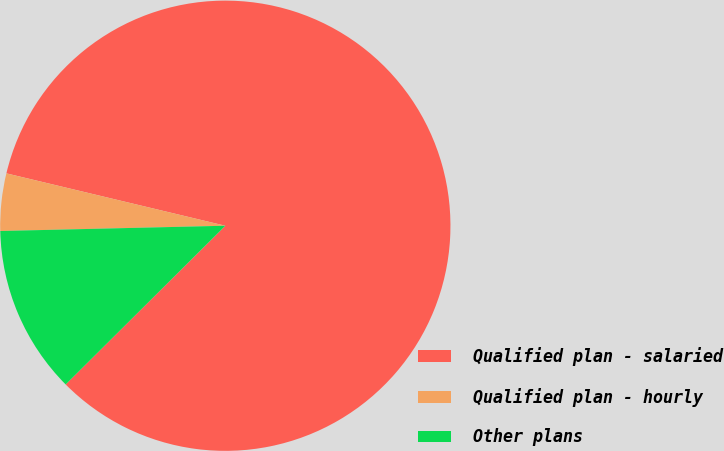<chart> <loc_0><loc_0><loc_500><loc_500><pie_chart><fcel>Qualified plan - salaried<fcel>Qualified plan - hourly<fcel>Other plans<nl><fcel>83.8%<fcel>4.11%<fcel>12.08%<nl></chart> 